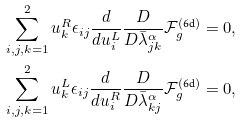<formula> <loc_0><loc_0><loc_500><loc_500>& \sum _ { i , j , k = 1 } ^ { 2 } u ^ { R } _ { k } \epsilon _ { i j } \frac { d } { d u ^ { L } _ { i } } \frac { D } { D \bar { \lambda } _ { j k } ^ { \alpha } } \mathcal { F } _ { g } ^ { ( \text {6d} ) } = 0 , \\ & \sum _ { i , j , k = 1 } ^ { 2 } u ^ { L } _ { k } \epsilon _ { i j } \frac { d } { d u ^ { R } _ { i } } \frac { D } { D \bar { \lambda } _ { k j } ^ { \alpha } } \mathcal { F } _ { g } ^ { ( \text {6d} ) } = 0 ,</formula> 